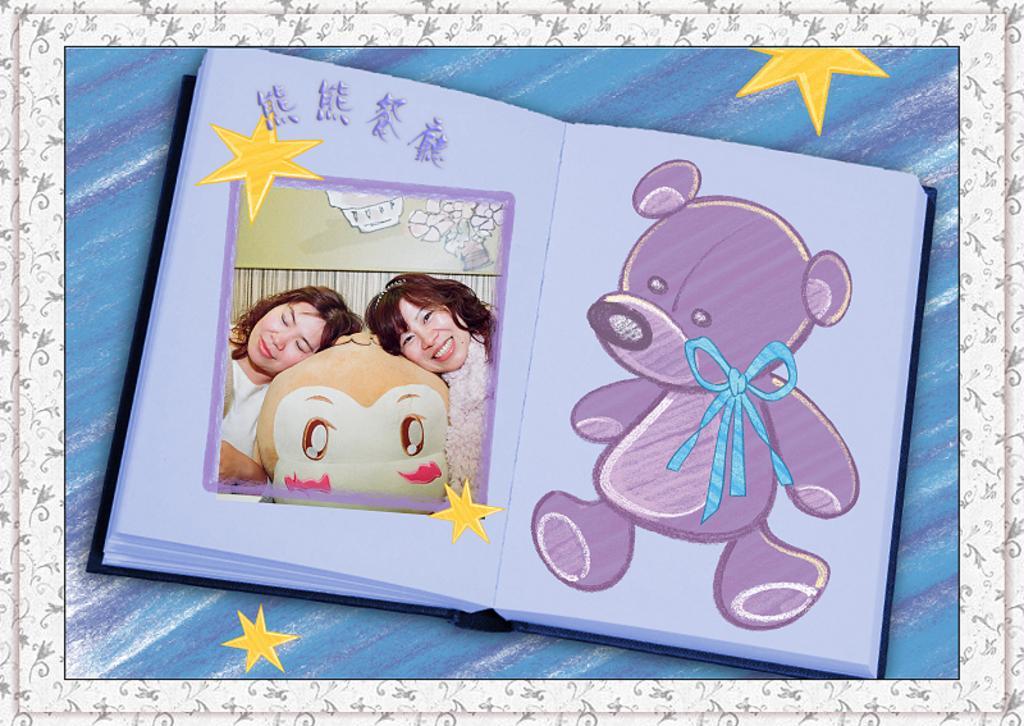Can you describe this image briefly? In this image there is a book and on the left there are two women and on the right there is a teddy painting. There are four yellow color stars in this image and it is edited. 